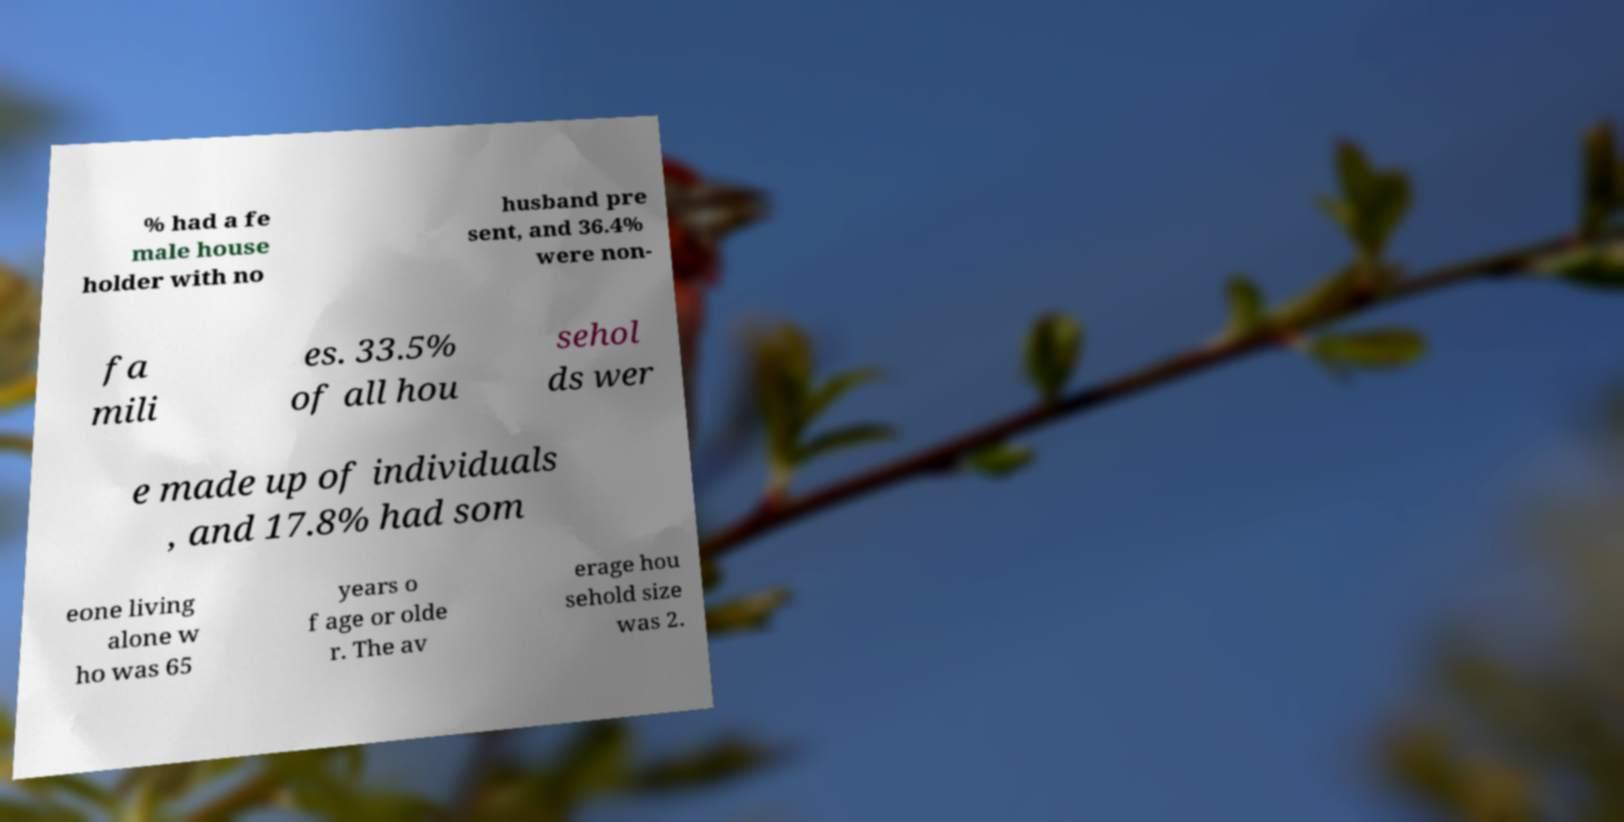What messages or text are displayed in this image? I need them in a readable, typed format. % had a fe male house holder with no husband pre sent, and 36.4% were non- fa mili es. 33.5% of all hou sehol ds wer e made up of individuals , and 17.8% had som eone living alone w ho was 65 years o f age or olde r. The av erage hou sehold size was 2. 